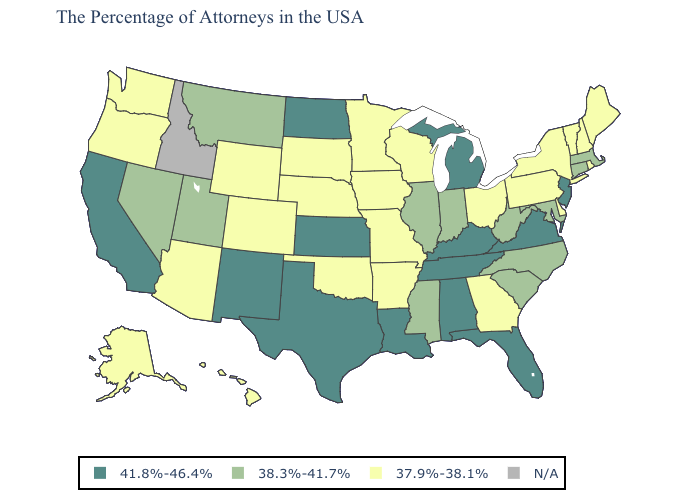Name the states that have a value in the range 41.8%-46.4%?
Be succinct. New Jersey, Virginia, Florida, Michigan, Kentucky, Alabama, Tennessee, Louisiana, Kansas, Texas, North Dakota, New Mexico, California. Name the states that have a value in the range 38.3%-41.7%?
Answer briefly. Massachusetts, Connecticut, Maryland, North Carolina, South Carolina, West Virginia, Indiana, Illinois, Mississippi, Utah, Montana, Nevada. Name the states that have a value in the range N/A?
Give a very brief answer. Idaho. Name the states that have a value in the range N/A?
Short answer required. Idaho. Name the states that have a value in the range N/A?
Keep it brief. Idaho. Among the states that border North Dakota , which have the lowest value?
Short answer required. Minnesota, South Dakota. Does Vermont have the lowest value in the Northeast?
Be succinct. Yes. What is the lowest value in the West?
Give a very brief answer. 37.9%-38.1%. Name the states that have a value in the range 37.9%-38.1%?
Concise answer only. Maine, Rhode Island, New Hampshire, Vermont, New York, Delaware, Pennsylvania, Ohio, Georgia, Wisconsin, Missouri, Arkansas, Minnesota, Iowa, Nebraska, Oklahoma, South Dakota, Wyoming, Colorado, Arizona, Washington, Oregon, Alaska, Hawaii. Which states hav the highest value in the MidWest?
Write a very short answer. Michigan, Kansas, North Dakota. Does Tennessee have the lowest value in the South?
Concise answer only. No. How many symbols are there in the legend?
Be succinct. 4. Does New York have the highest value in the USA?
Be succinct. No. Which states have the highest value in the USA?
Keep it brief. New Jersey, Virginia, Florida, Michigan, Kentucky, Alabama, Tennessee, Louisiana, Kansas, Texas, North Dakota, New Mexico, California. Name the states that have a value in the range 37.9%-38.1%?
Write a very short answer. Maine, Rhode Island, New Hampshire, Vermont, New York, Delaware, Pennsylvania, Ohio, Georgia, Wisconsin, Missouri, Arkansas, Minnesota, Iowa, Nebraska, Oklahoma, South Dakota, Wyoming, Colorado, Arizona, Washington, Oregon, Alaska, Hawaii. 